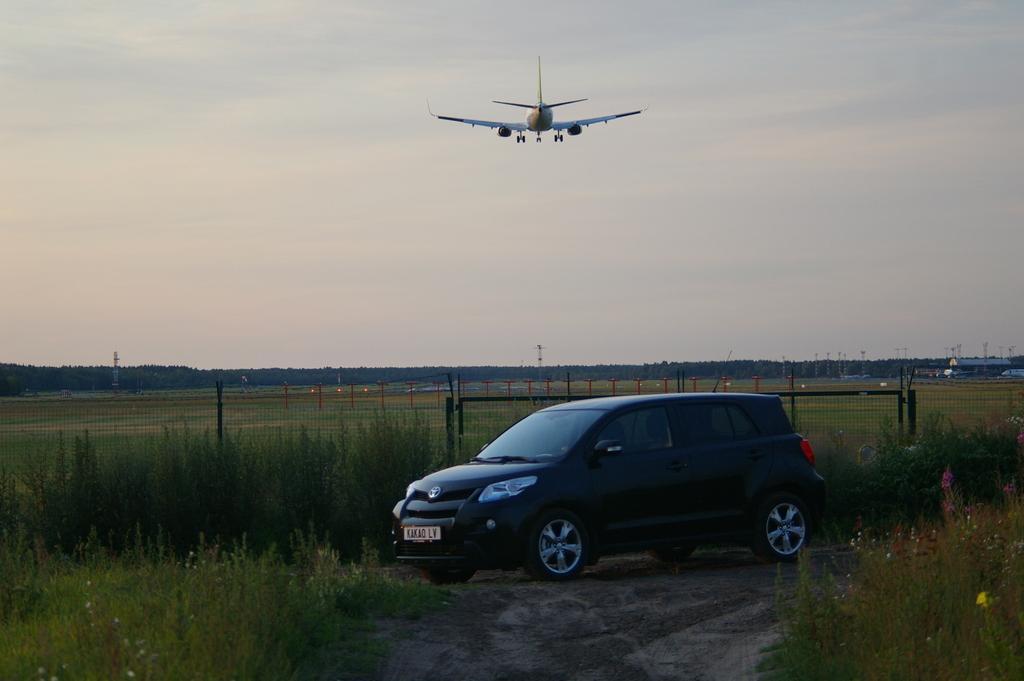Describe this image in one or two sentences. In the center of the image we can see a car. At the bottom there is grass and we can see fence. At the top there is an aeroplane flying in the sky. 